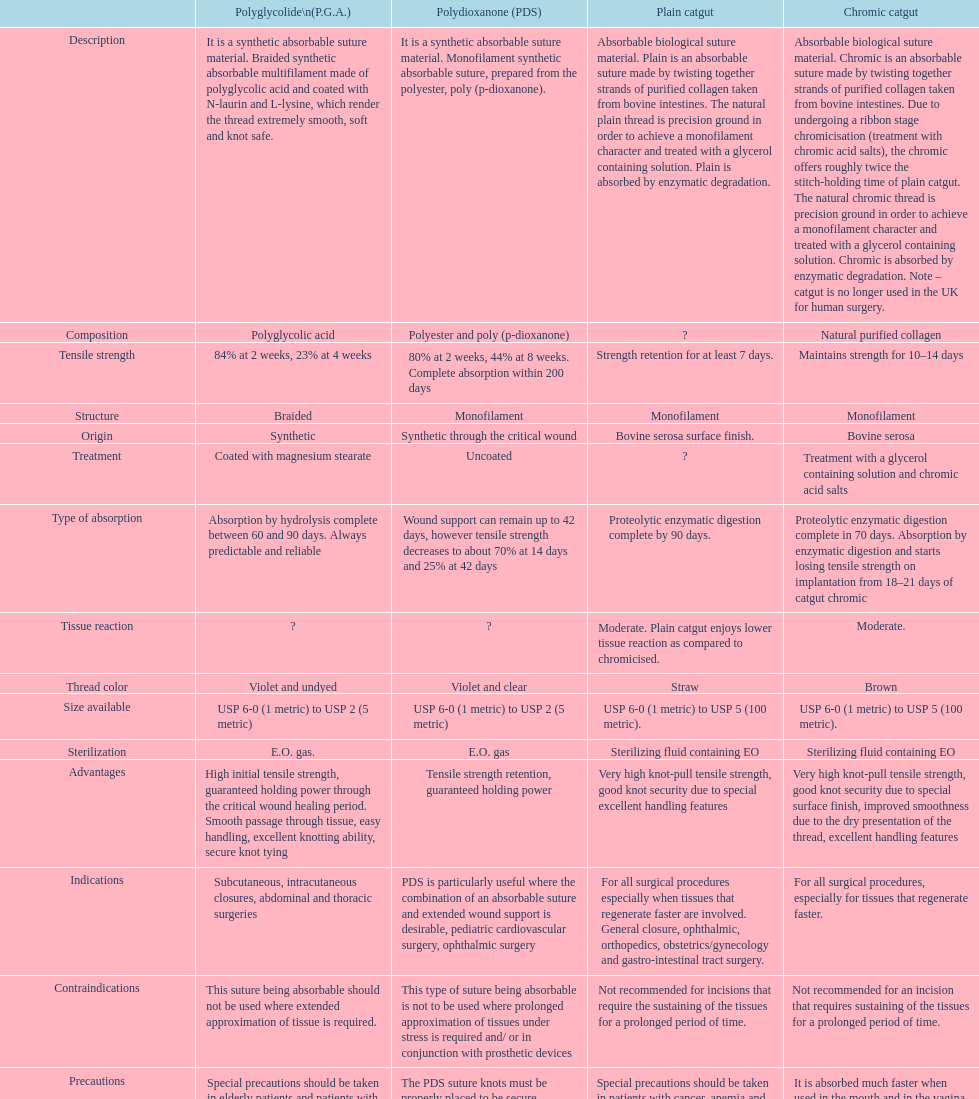Which kind of suture should not be utilized alongside prosthetic devices? Polydioxanone (PDS). 